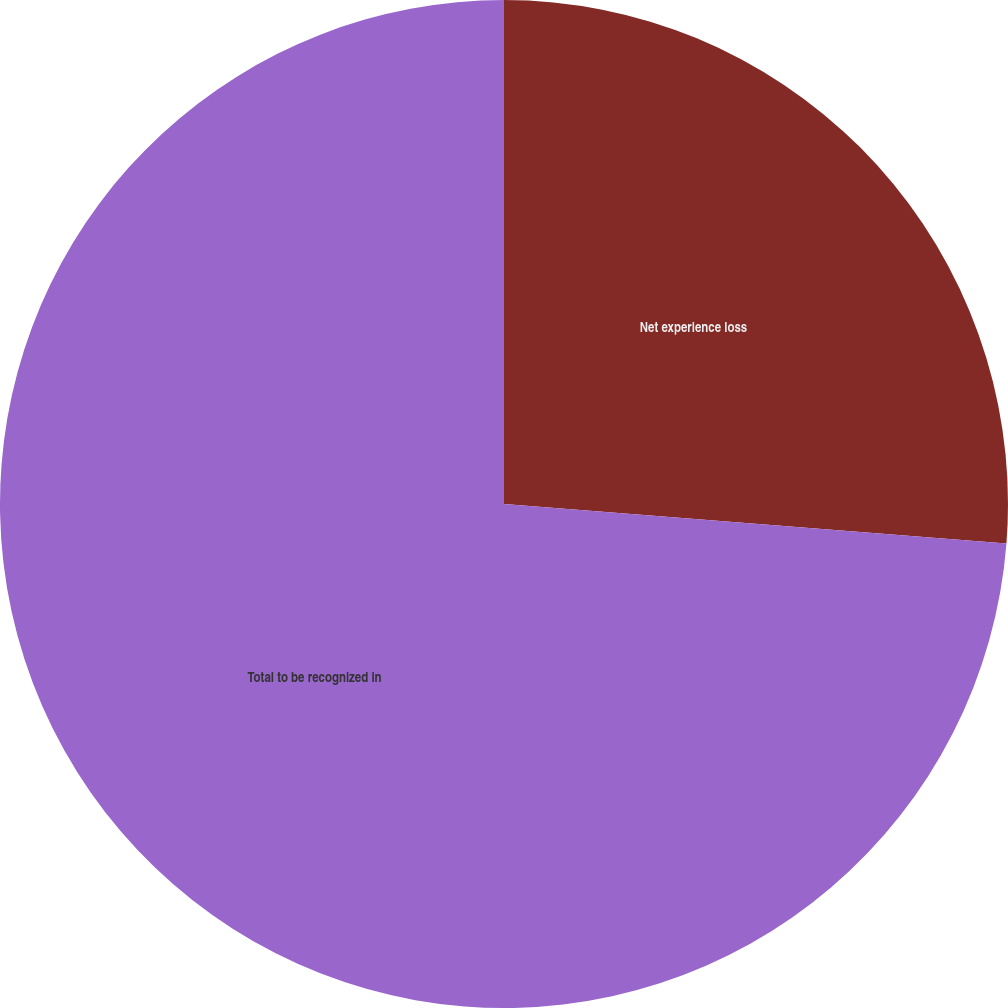Convert chart to OTSL. <chart><loc_0><loc_0><loc_500><loc_500><pie_chart><fcel>Net experience loss<fcel>Total to be recognized in<nl><fcel>26.25%<fcel>73.75%<nl></chart> 